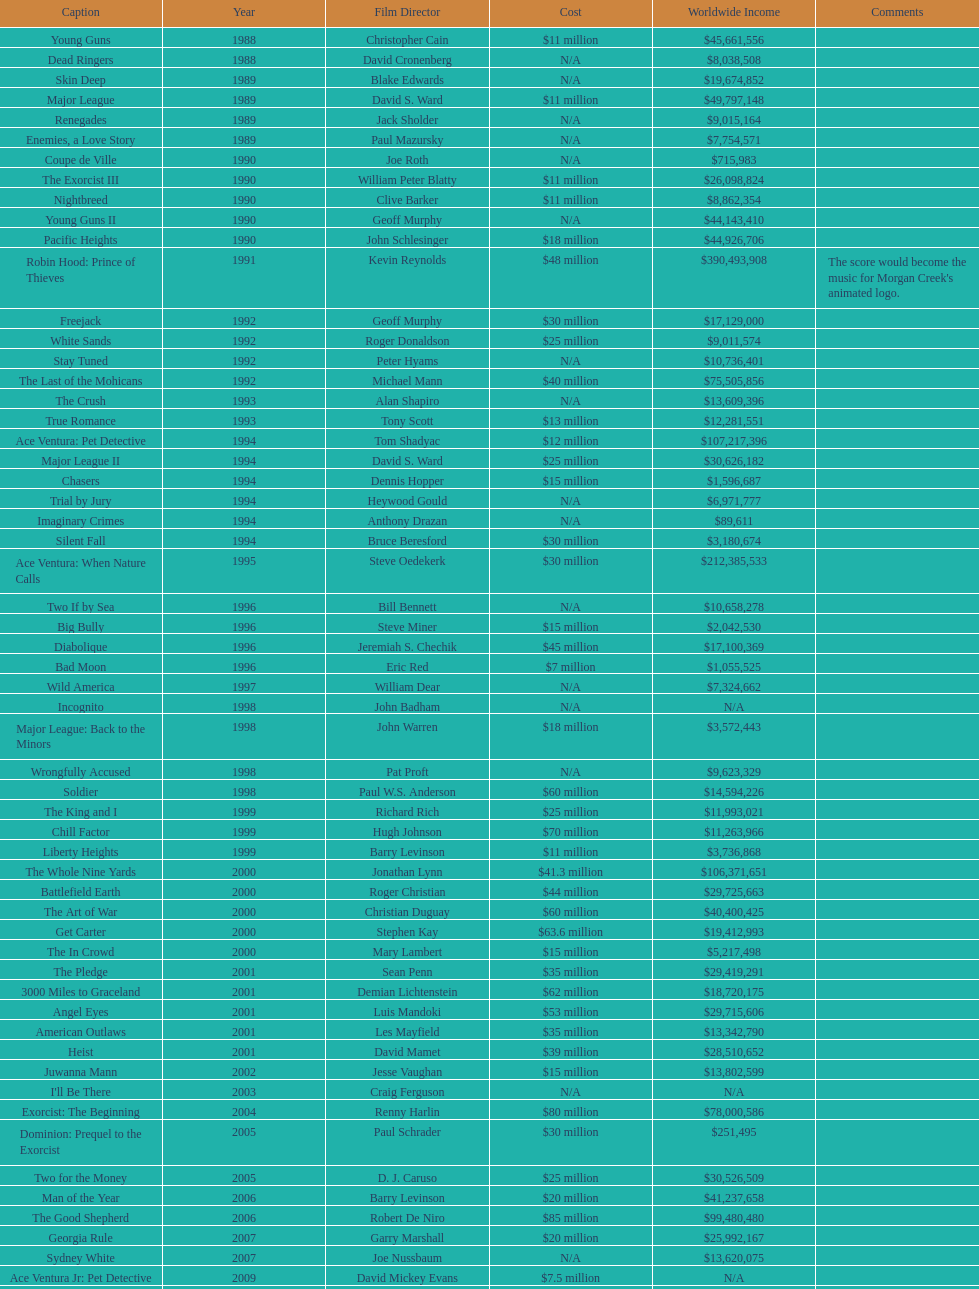What is the number of films directed by david s. ward? 2. 